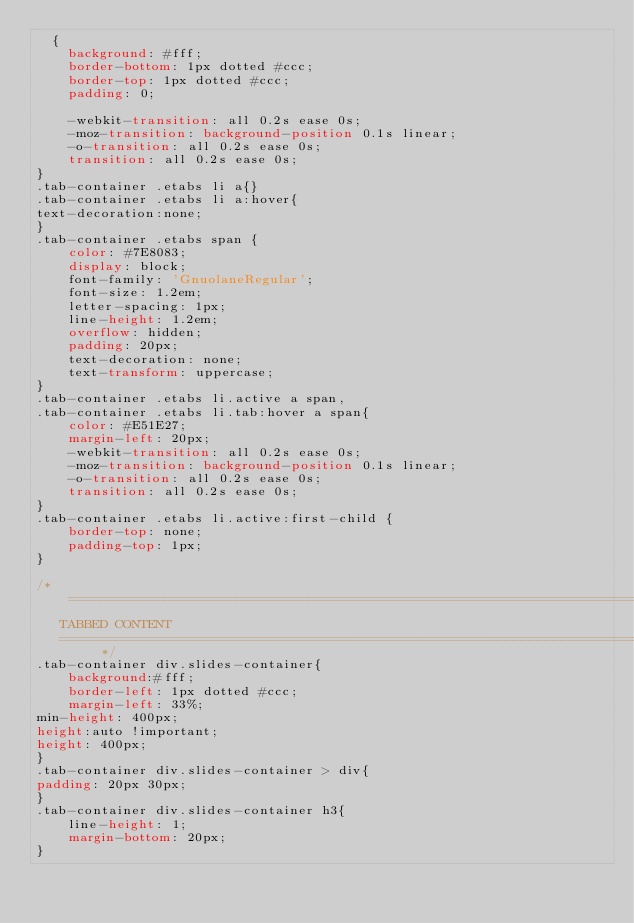Convert code to text. <code><loc_0><loc_0><loc_500><loc_500><_CSS_>  {
    background: #fff;
    border-bottom: 1px dotted #ccc;
    border-top: 1px dotted #ccc;
    padding: 0;
	
	-webkit-transition: all 0.2s ease 0s;
	-moz-transition: background-position 0.1s linear;
	-o-transition: all 0.2s ease 0s;
	transition: all 0.2s ease 0s;	
}
.tab-container .etabs li a{}
.tab-container .etabs li a:hover{
text-decoration:none;
}
.tab-container .etabs span {
    color: #7E8083;
    display: block;
    font-family: 'GnuolaneRegular';
    font-size: 1.2em;
    letter-spacing: 1px;
    line-height: 1.2em;
    overflow: hidden;
    padding: 20px;
    text-decoration: none;
    text-transform: uppercase;
}
.tab-container .etabs li.active a span, 
.tab-container .etabs li.tab:hover a span{
	color: #E51E27;
	margin-left: 20px;
	-webkit-transition: all 0.2s ease 0s;
	-moz-transition: background-position 0.1s linear;
	-o-transition: all 0.2s ease 0s;
	transition: all 0.2s ease 0s;
}
.tab-container .etabs li.active:first-child {
    border-top: none;
    padding-top: 1px;
}

/* =============================================================================
   TABBED CONTENT
   ========================================================================== */
.tab-container div.slides-container{
    background:#fff;
    border-left: 1px dotted #ccc;
    margin-left: 33%;
min-height: 400px; 
height:auto !important; 
height: 400px;
}
.tab-container div.slides-container > div{
padding: 20px 30px;
}
.tab-container div.slides-container h3{
    line-height: 1;
    margin-bottom: 20px;
}</code> 